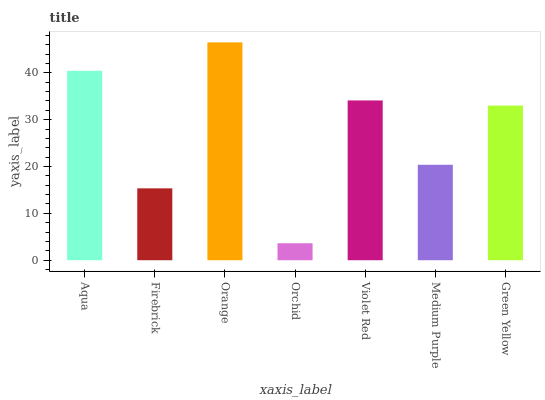Is Orchid the minimum?
Answer yes or no. Yes. Is Orange the maximum?
Answer yes or no. Yes. Is Firebrick the minimum?
Answer yes or no. No. Is Firebrick the maximum?
Answer yes or no. No. Is Aqua greater than Firebrick?
Answer yes or no. Yes. Is Firebrick less than Aqua?
Answer yes or no. Yes. Is Firebrick greater than Aqua?
Answer yes or no. No. Is Aqua less than Firebrick?
Answer yes or no. No. Is Green Yellow the high median?
Answer yes or no. Yes. Is Green Yellow the low median?
Answer yes or no. Yes. Is Aqua the high median?
Answer yes or no. No. Is Orchid the low median?
Answer yes or no. No. 